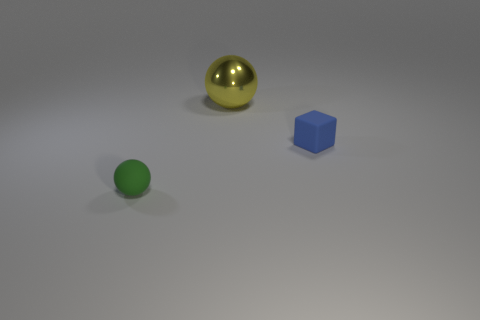Is there anything else that is the same shape as the tiny blue rubber thing?
Offer a very short reply. No. Is the material of the tiny object in front of the small blue rubber cube the same as the yellow sphere?
Give a very brief answer. No. Is there anything else that has the same material as the small block?
Your response must be concise. Yes. What is the color of the thing that is the same size as the matte block?
Give a very brief answer. Green. Is there a thing of the same color as the big shiny ball?
Keep it short and to the point. No. What size is the blue thing that is made of the same material as the tiny green thing?
Offer a very short reply. Small. How many other things are the same size as the yellow metallic thing?
Your response must be concise. 0. There is a tiny object that is to the right of the tiny green thing; what is it made of?
Ensure brevity in your answer.  Rubber. What is the shape of the matte object that is left of the sphere behind the small rubber thing that is left of the blue rubber object?
Ensure brevity in your answer.  Sphere. Do the blue object and the yellow thing have the same size?
Provide a short and direct response. No. 